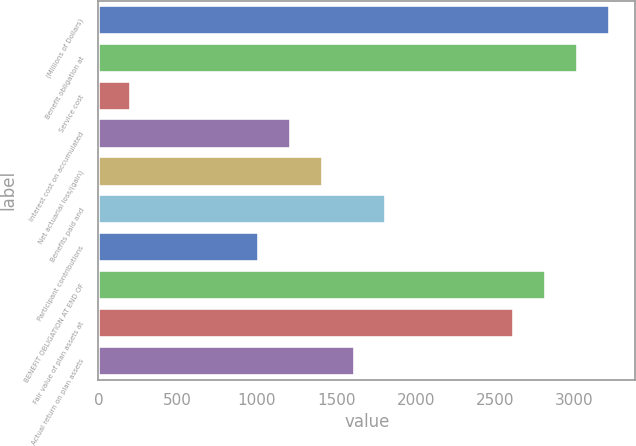Convert chart to OTSL. <chart><loc_0><loc_0><loc_500><loc_500><bar_chart><fcel>(Millions of Dollars)<fcel>Benefit obligation at<fcel>Service cost<fcel>Interest cost on accumulated<fcel>Net actuarial loss/(gain)<fcel>Benefits paid and<fcel>Participant contributions<fcel>BENEFIT OBLIGATION AT END OF<fcel>Fair value of plan assets at<fcel>Actual return on plan assets<nl><fcel>3221.4<fcel>3020.5<fcel>207.9<fcel>1212.4<fcel>1413.3<fcel>1815.1<fcel>1011.5<fcel>2819.6<fcel>2618.7<fcel>1614.2<nl></chart> 